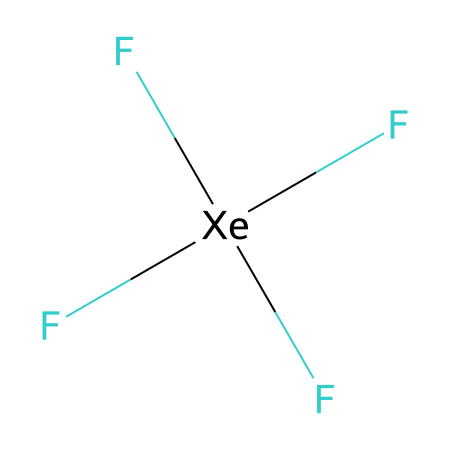What is the central atom in xenon tetrafluoride? The central atom in the structure is indicated by the 'Xe' (xenon) symbol, which is surrounded by four fluorine (F) atoms, forming the compound.
Answer: xenon How many fluorine atoms are bonded to xenon in this compound? The SMILES representation shows 'F[Xe](F)(F)F', indicating that there are four fluorine (F) atoms attached to the xenon (Xe) atom.
Answer: four What is the hybridization of the central atom in xenon tetrafluoride? The xenon atom, being bonded to four fluorine atoms and having one lone pair, undergoes sp³d hybridization to accommodate the five electron pairs around it.
Answer: sp³d How many lone pairs are present on the central xenon atom? The structure suggests that xenon has one lone pair as it forms four bonds with fluorine atoms, making a total of five electron regions of density.
Answer: one What type of compound is xenon tetrafluoride classified as? Xenon tetrafluoride is classified as a hypervalent compound because the central xenon atom is surrounded by more than four valence electrons, exhibiting an expanded octet.
Answer: hypervalent 